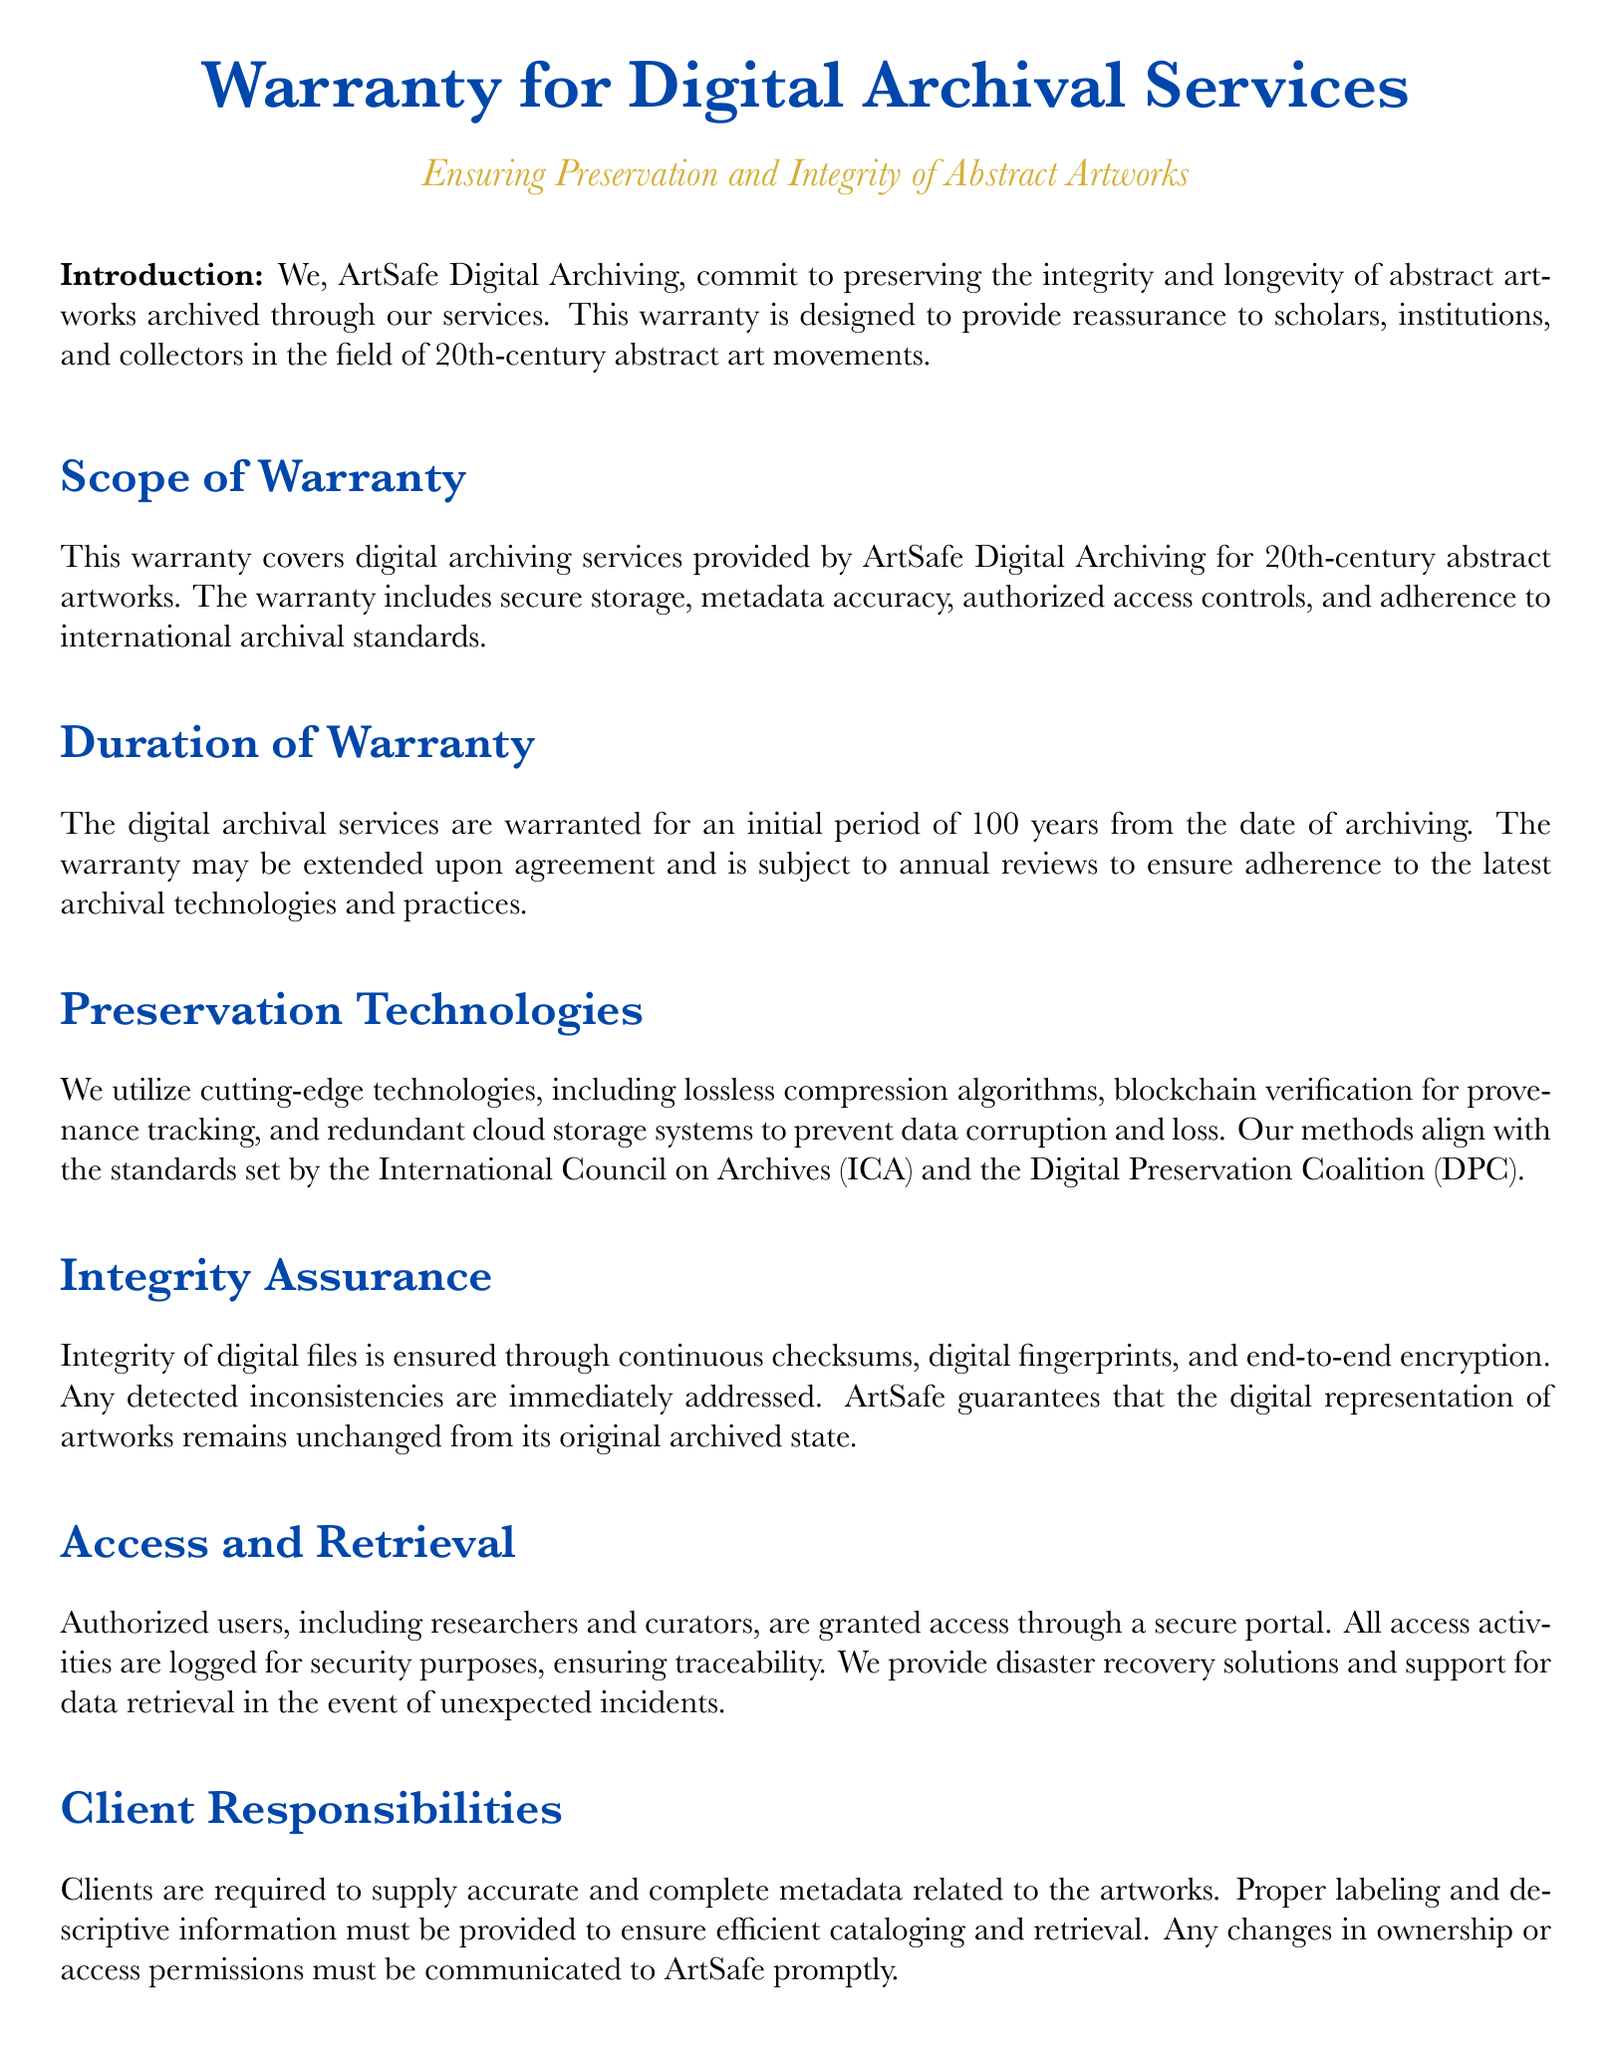What is the duration of the warranty? The warranty duration is specified in the section dedicated to warranty duration, which is 100 years from the date of archiving.
Answer: 100 years What company provides the digital archival services? The document introduces the company responsible for providing these services in the introduction section.
Answer: ArtSafe Digital Archiving What is the primary purpose of this warranty? The document states that the warranty is designed to provide reassurance to stakeholders in the field of abstract art regarding preservation and integrity.
Answer: Preservation and integrity What is one technology mentioned for preserving digital files? The warranty outlines various technologies used for preservation in the preservation technologies section.
Answer: Blockchain verification Who has access to the digital archival services? The document specifies who is granted access in the access and retrieval section, highlighting authorized users.
Answer: Researchers and curators What must clients supply for the archival process? Client responsibilities detail what clients must provide to ensure efficient services, mentioning specific information.
Answer: Accurate and complete metadata What kind of incidents does ArtSafe provide solutions for? The access and retrieval section mentions solutions for unexpected incidents that might affect data.
Answer: Disaster recovery solutions Which organization sets the standards that ArtSafe's methods align with? The preservation technologies section references an important organization related to archival standards.
Answer: International Council on Archives 